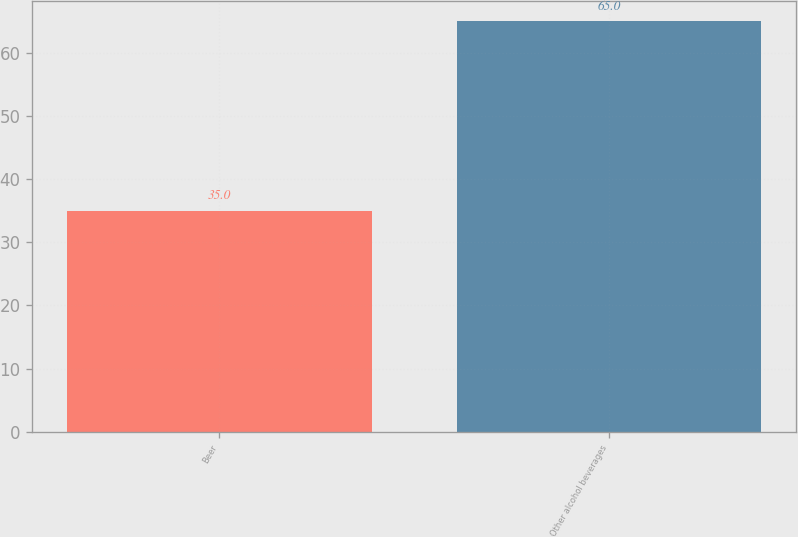Convert chart to OTSL. <chart><loc_0><loc_0><loc_500><loc_500><bar_chart><fcel>Beer<fcel>Other alcohol beverages<nl><fcel>35<fcel>65<nl></chart> 